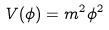Convert formula to latex. <formula><loc_0><loc_0><loc_500><loc_500>V ( \phi ) = m ^ { 2 } \phi ^ { 2 }</formula> 